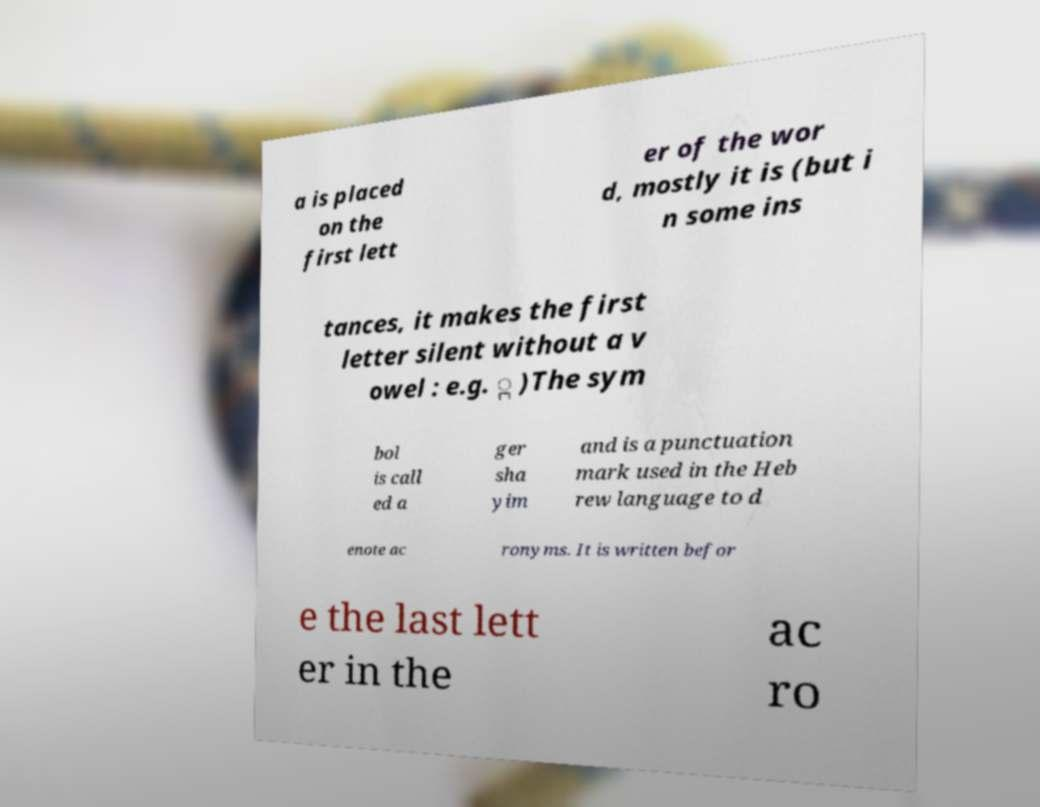Can you read and provide the text displayed in the image?This photo seems to have some interesting text. Can you extract and type it out for me? a is placed on the first lett er of the wor d, mostly it is (but i n some ins tances, it makes the first letter silent without a v owel : e.g. ְ )The sym bol is call ed a ger sha yim and is a punctuation mark used in the Heb rew language to d enote ac ronyms. It is written befor e the last lett er in the ac ro 